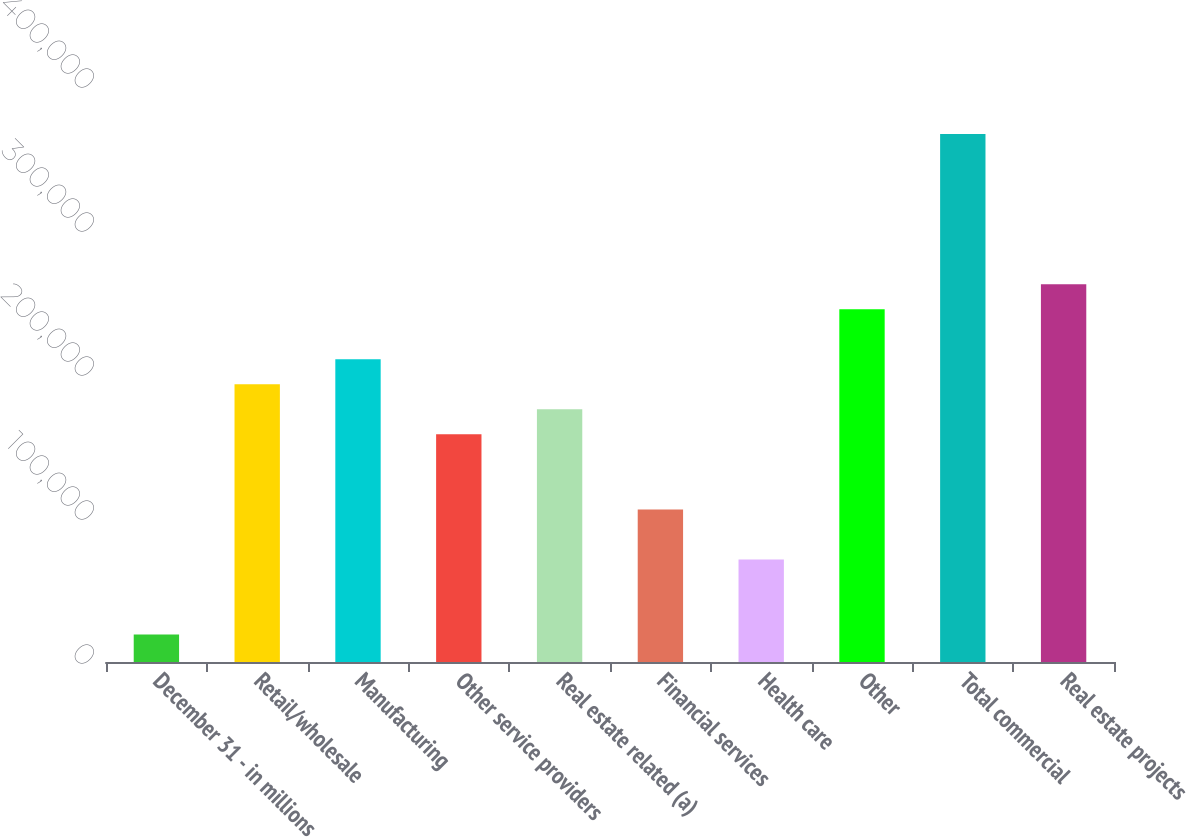<chart> <loc_0><loc_0><loc_500><loc_500><bar_chart><fcel>December 31 - in millions<fcel>Retail/wholesale<fcel>Manufacturing<fcel>Other service providers<fcel>Real estate related (a)<fcel>Financial services<fcel>Health care<fcel>Other<fcel>Total commercial<fcel>Real estate projects<nl><fcel>19049.2<fcel>192871<fcel>210253<fcel>158107<fcel>175489<fcel>105960<fcel>71195.8<fcel>245018<fcel>366693<fcel>262400<nl></chart> 